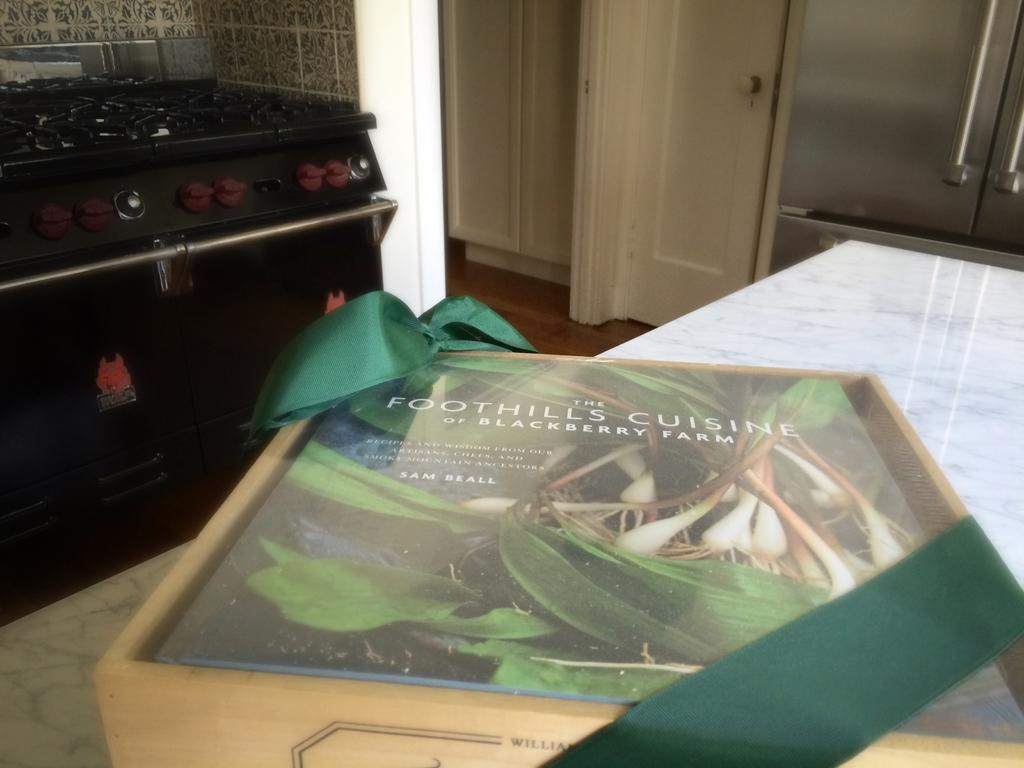Provide a one-sentence caption for the provided image. A book titled Foothills Cuisine sitting on a marble counter in a kitchen. 